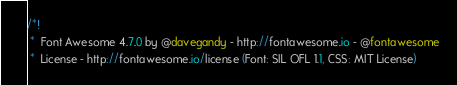Convert code to text. <code><loc_0><loc_0><loc_500><loc_500><_CSS_>/*!
 *  Font Awesome 4.7.0 by @davegandy - http://fontawesome.io - @fontawesome
 *  License - http://fontawesome.io/license (Font: SIL OFL 1.1, CSS: MIT License)</code> 